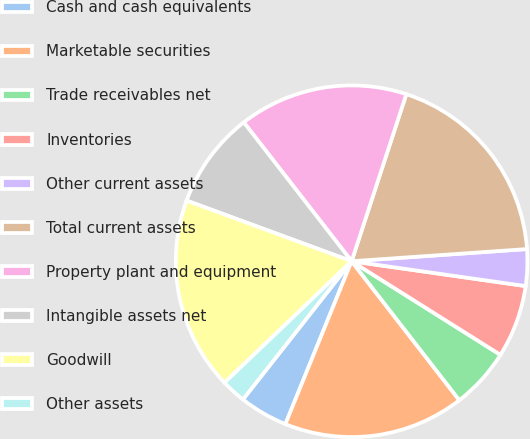<chart> <loc_0><loc_0><loc_500><loc_500><pie_chart><fcel>Cash and cash equivalents<fcel>Marketable securities<fcel>Trade receivables net<fcel>Inventories<fcel>Other current assets<fcel>Total current assets<fcel>Property plant and equipment<fcel>Intangible assets net<fcel>Goodwill<fcel>Other assets<nl><fcel>4.46%<fcel>16.64%<fcel>5.57%<fcel>6.68%<fcel>3.36%<fcel>18.86%<fcel>15.54%<fcel>8.89%<fcel>17.75%<fcel>2.25%<nl></chart> 